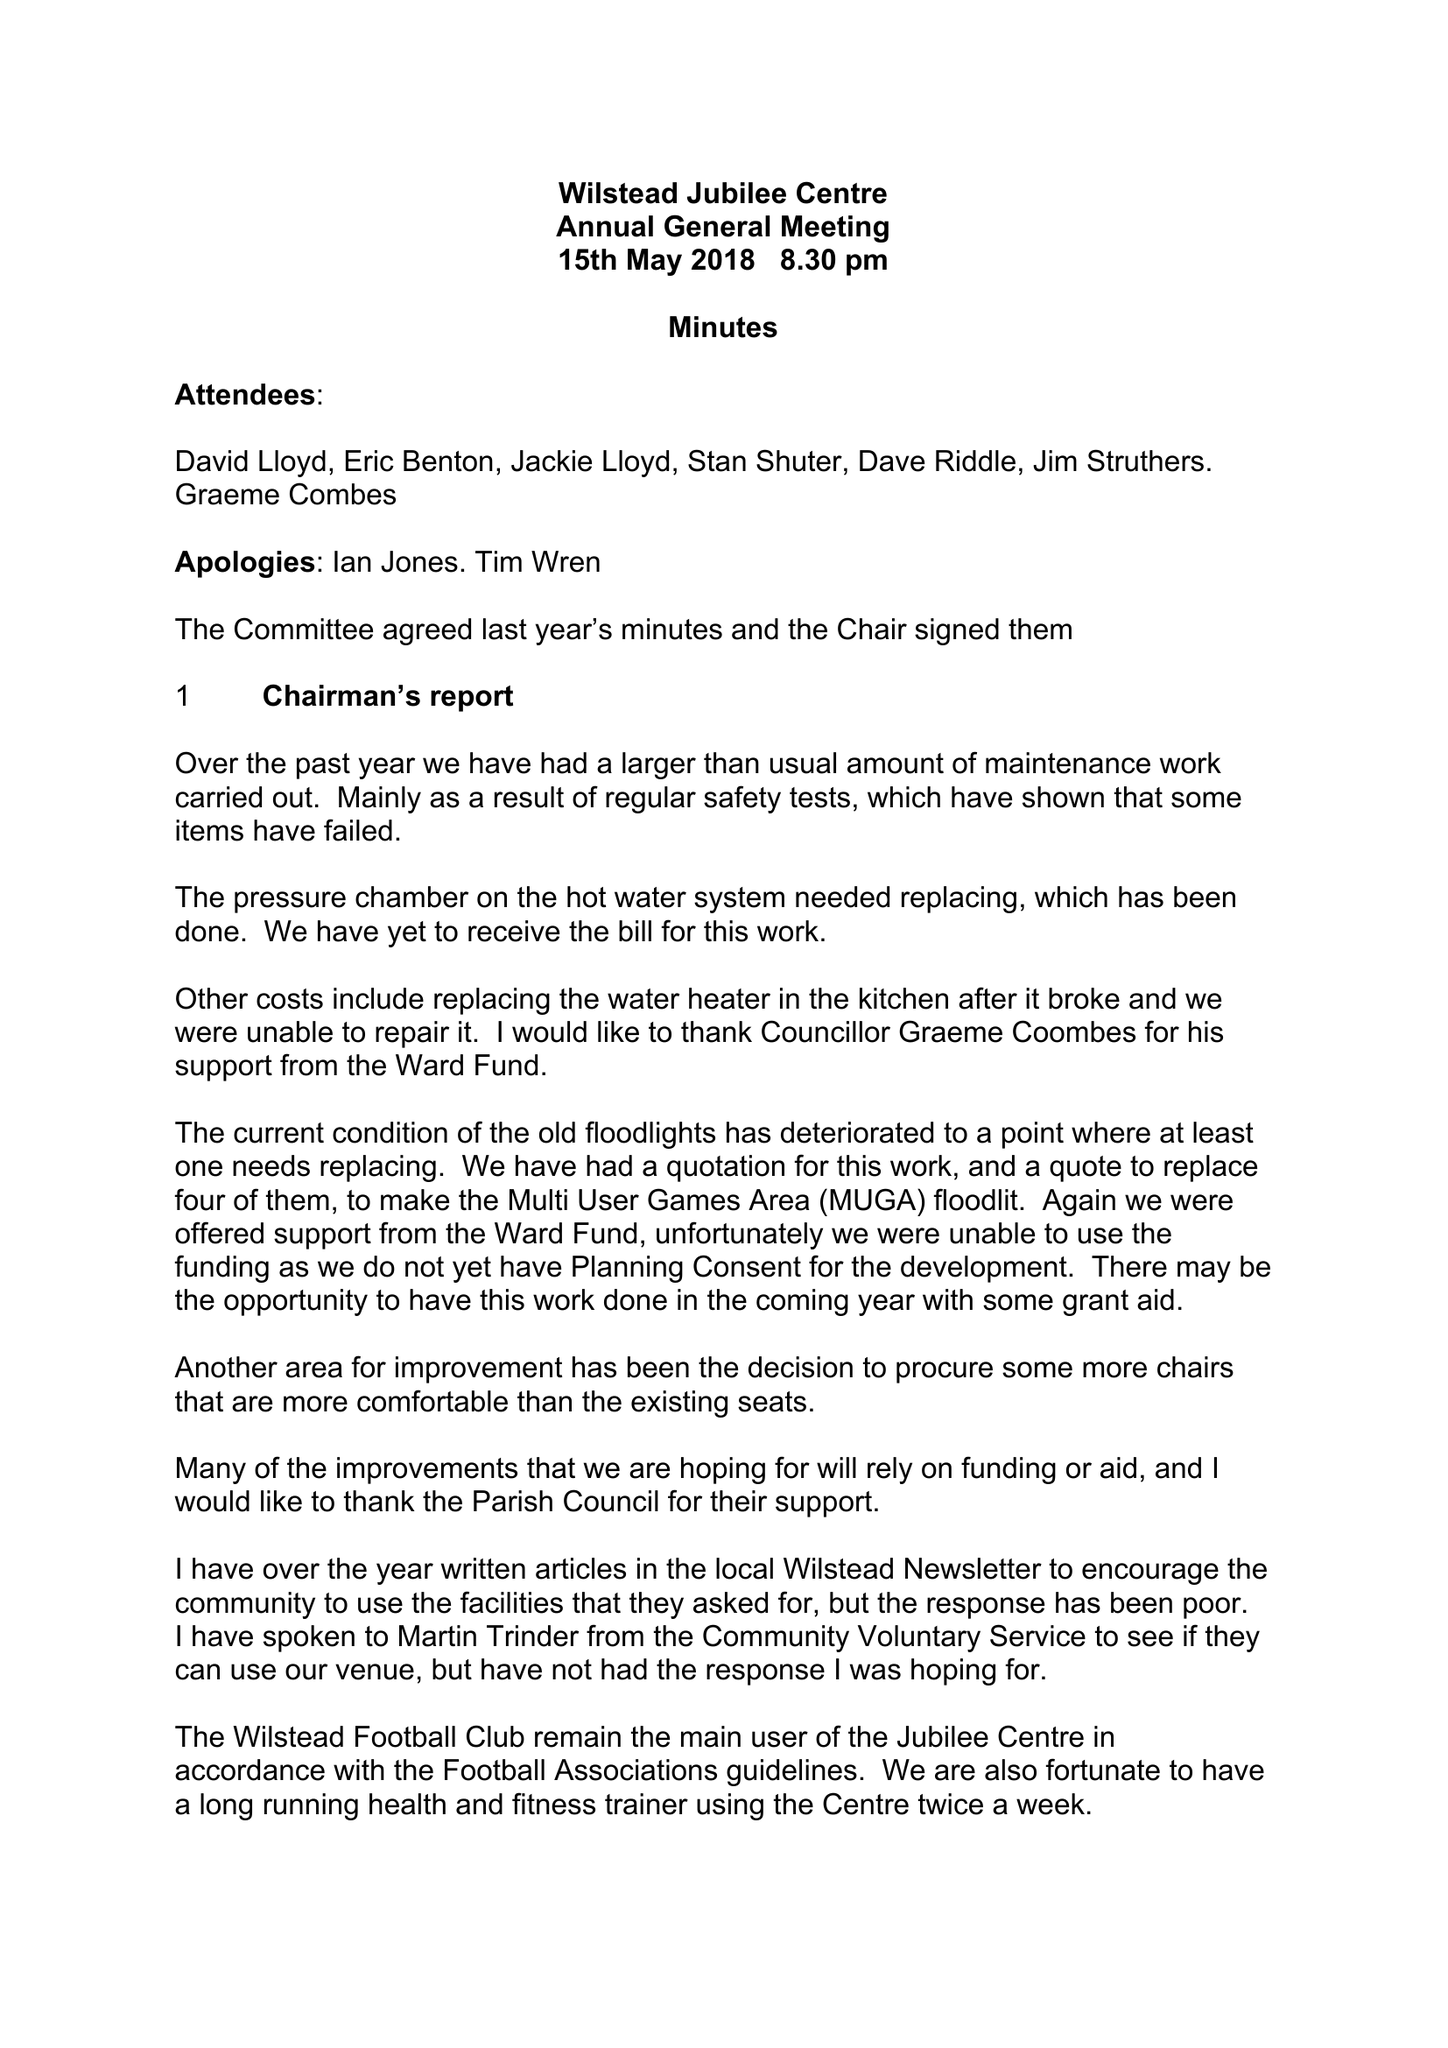What is the value for the report_date?
Answer the question using a single word or phrase. 2018-03-31 